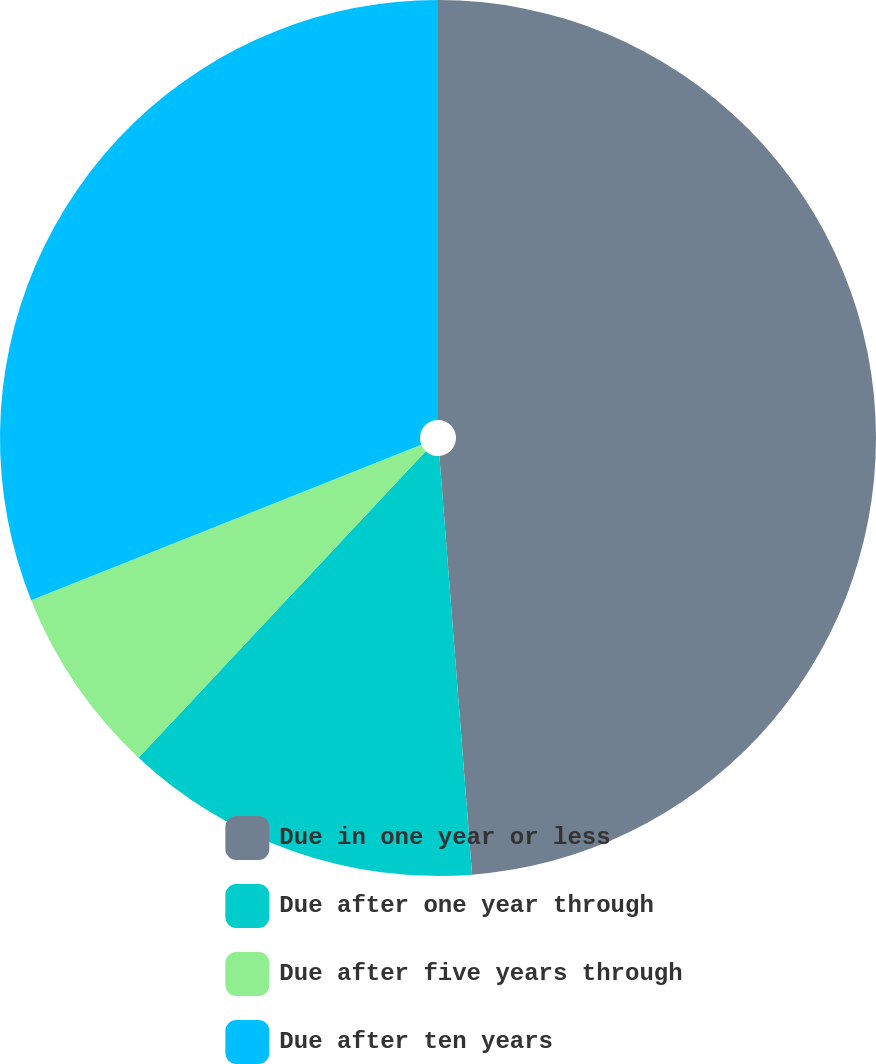Convert chart to OTSL. <chart><loc_0><loc_0><loc_500><loc_500><pie_chart><fcel>Due in one year or less<fcel>Due after one year through<fcel>Due after five years through<fcel>Due after ten years<nl><fcel>48.76%<fcel>13.22%<fcel>6.98%<fcel>31.04%<nl></chart> 